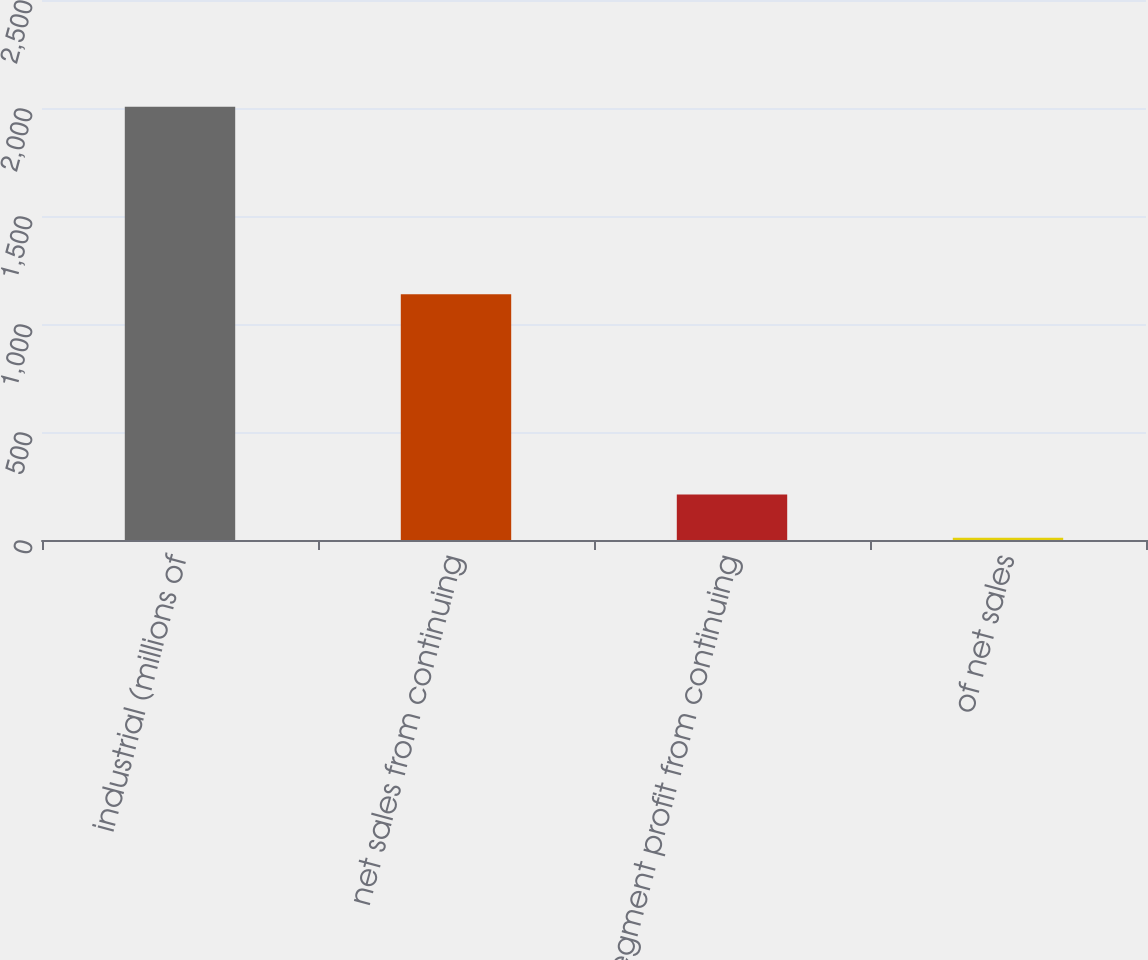Convert chart. <chart><loc_0><loc_0><loc_500><loc_500><bar_chart><fcel>industrial (millions of<fcel>net sales from continuing<fcel>Segment profit from continuing<fcel>of net sales<nl><fcel>2006<fcel>1138<fcel>210.41<fcel>10.9<nl></chart> 